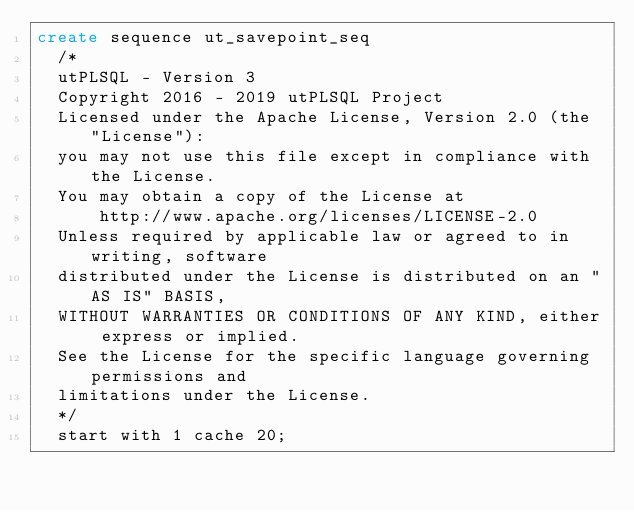<code> <loc_0><loc_0><loc_500><loc_500><_SQL_>create sequence ut_savepoint_seq
  /*
  utPLSQL - Version 3
  Copyright 2016 - 2019 utPLSQL Project
  Licensed under the Apache License, Version 2.0 (the "License"):
  you may not use this file except in compliance with the License.
  You may obtain a copy of the License at
      http://www.apache.org/licenses/LICENSE-2.0
  Unless required by applicable law or agreed to in writing, software
  distributed under the License is distributed on an "AS IS" BASIS,
  WITHOUT WARRANTIES OR CONDITIONS OF ANY KIND, either express or implied.
  See the License for the specific language governing permissions and
  limitations under the License.
  */
  start with 1 cache 20;</code> 